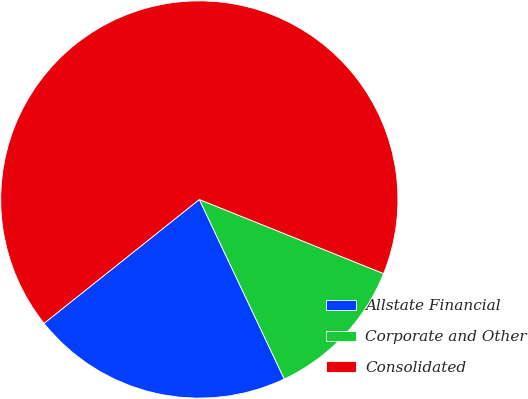Convert chart to OTSL. <chart><loc_0><loc_0><loc_500><loc_500><pie_chart><fcel>Allstate Financial<fcel>Corporate and Other<fcel>Consolidated<nl><fcel>21.32%<fcel>11.88%<fcel>66.8%<nl></chart> 